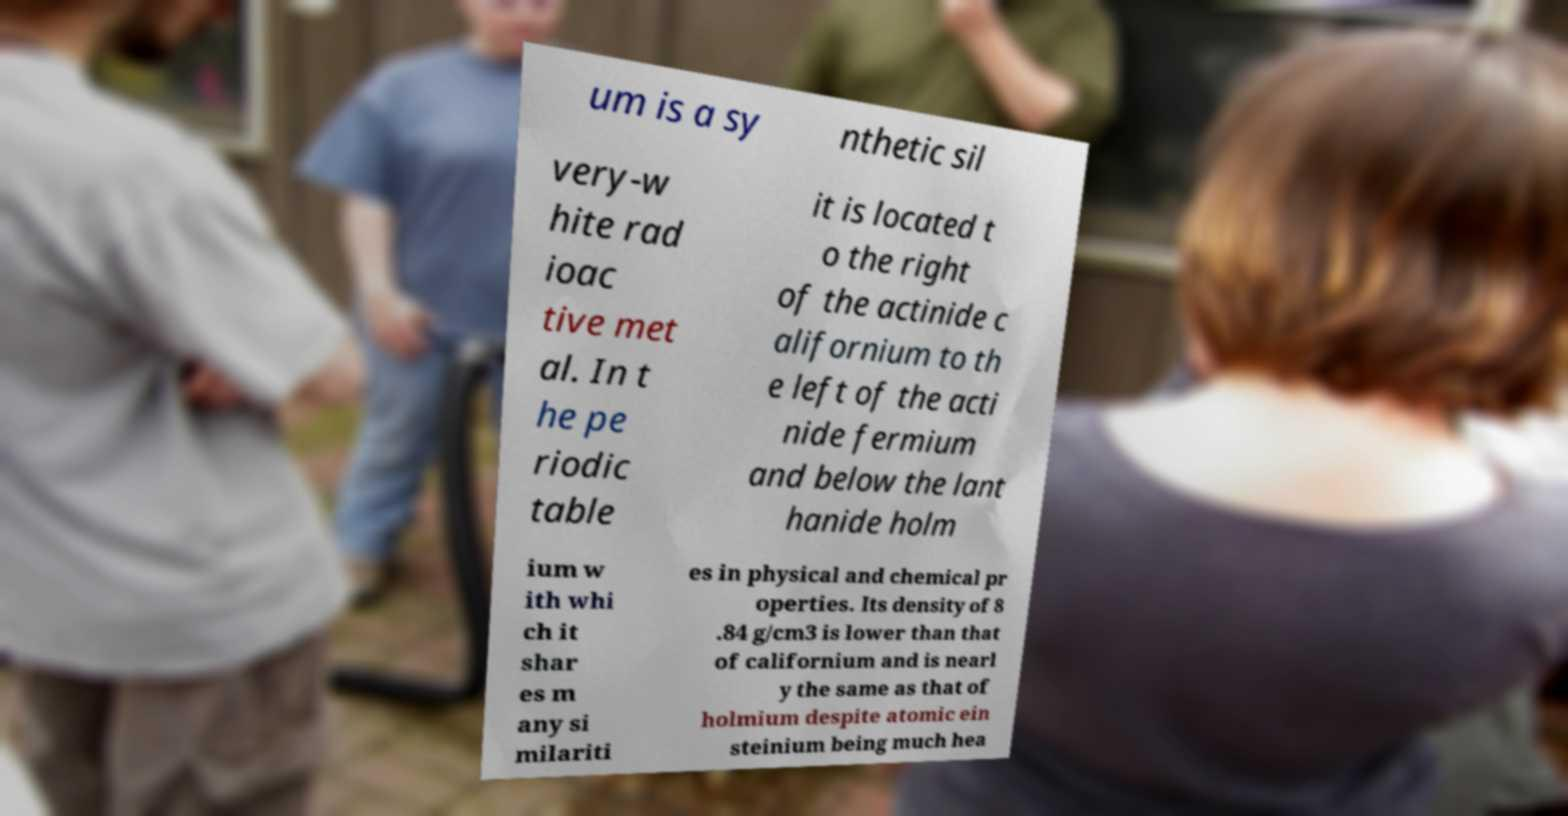Please read and relay the text visible in this image. What does it say? um is a sy nthetic sil very-w hite rad ioac tive met al. In t he pe riodic table it is located t o the right of the actinide c alifornium to th e left of the acti nide fermium and below the lant hanide holm ium w ith whi ch it shar es m any si milariti es in physical and chemical pr operties. Its density of 8 .84 g/cm3 is lower than that of californium and is nearl y the same as that of holmium despite atomic ein steinium being much hea 